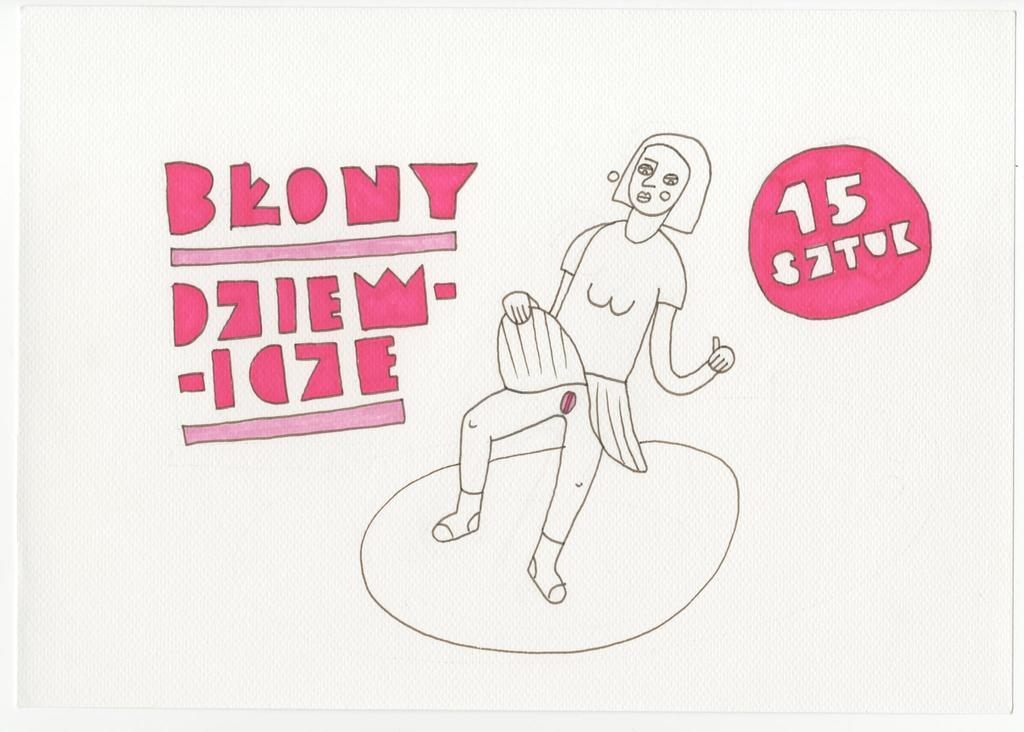What is the main object in the image? There is a white color tissue paper-like object in the image. What is depicted on the tissue paper? There is a sketch on the tissue paper. Is there any text on the tissue paper? Something is written on both sides of the tissue paper. What month is depicted on the jar in the image? There is no jar present in the image, and therefore no month can be associated with it. 